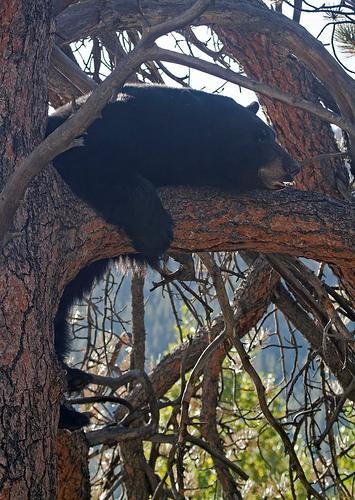If you were to create an advertisement for a nature park based on this image, what would the tagline be? Discover the wonders of nature – where animals peacefully frolic amidst the green foliage and towering trees. Which type of tree is the bear climbing? Ponderosa pine In a single sentence, describe how the bear's physical strength is displayed in the image. The bear's physical strength is showcased as it effortlessly holds on to the tree limb with its muscular paw and balances its body while climbing. Using a hypothetical situation, reply to someone asking for this bear's state of mind as if you could talk to bears. Well, if I could ask the bear, it might say it's just feeling a bit lazy and enjoying a relaxing moment on the tree limb. Imagine you're a tour guide and you're describing this image to visitors. What would you say? Ladies and gentlemen, behold the beauty of this black bear, as it expertly climbs a dead pine, embracing the limb in its powerful arms. Notice how it effortlessly balances itself, all while enjoying the vast green landscape. Answer the question: What is the bear doing with its mouth in the image? The bear has its mouth open, showing its pink tongue. Challenge yourself to describe the image using some artistic flair. In nature's soothing embrace, a black bear cozily hugs a ponderosa pine, finding solace amidst the tangled chaos of barren branches. Using simple language, describe the primary action taking place in the image. Black bear is climbing a tree and hugging its branch. If you were writing a children's storybook based on this image, what could be the title of the story? "The Adventures of Bearry the Bear and the Magical Ponderosa Pine" 